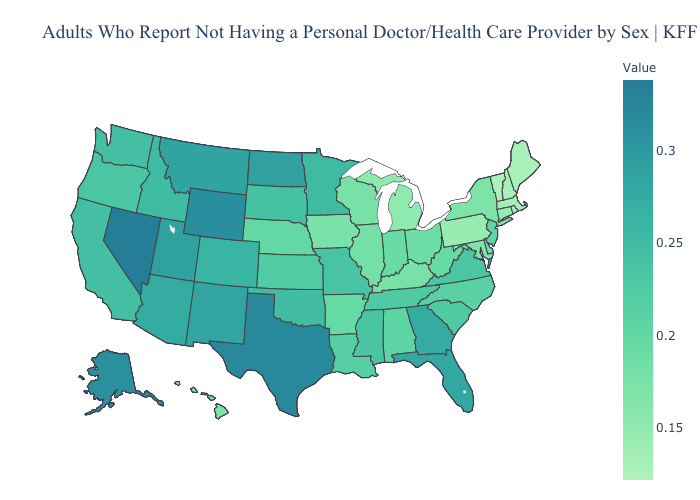Which states have the highest value in the USA?
Concise answer only. Nevada. Among the states that border Arizona , which have the highest value?
Short answer required. Nevada. Which states have the lowest value in the Northeast?
Short answer required. Rhode Island. Does Massachusetts have the highest value in the USA?
Answer briefly. No. Which states have the lowest value in the South?
Concise answer only. Maryland. Which states have the lowest value in the USA?
Short answer required. Rhode Island. 